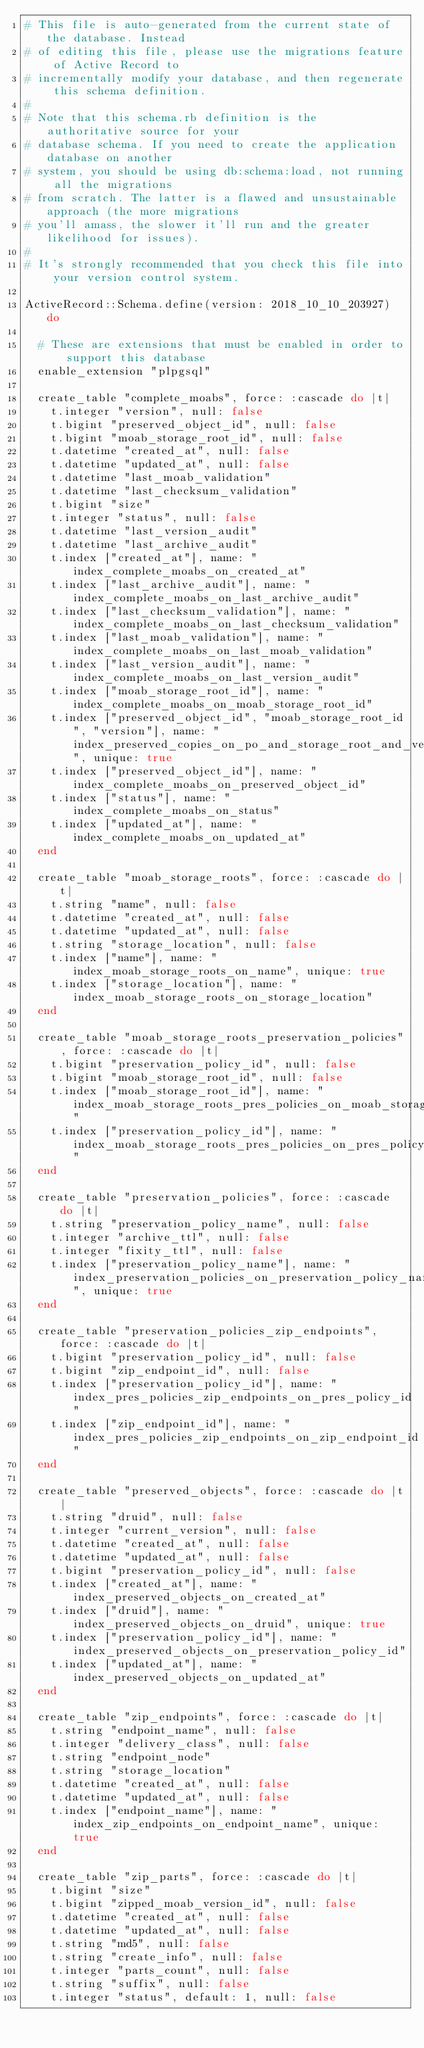Convert code to text. <code><loc_0><loc_0><loc_500><loc_500><_Ruby_># This file is auto-generated from the current state of the database. Instead
# of editing this file, please use the migrations feature of Active Record to
# incrementally modify your database, and then regenerate this schema definition.
#
# Note that this schema.rb definition is the authoritative source for your
# database schema. If you need to create the application database on another
# system, you should be using db:schema:load, not running all the migrations
# from scratch. The latter is a flawed and unsustainable approach (the more migrations
# you'll amass, the slower it'll run and the greater likelihood for issues).
#
# It's strongly recommended that you check this file into your version control system.

ActiveRecord::Schema.define(version: 2018_10_10_203927) do

  # These are extensions that must be enabled in order to support this database
  enable_extension "plpgsql"

  create_table "complete_moabs", force: :cascade do |t|
    t.integer "version", null: false
    t.bigint "preserved_object_id", null: false
    t.bigint "moab_storage_root_id", null: false
    t.datetime "created_at", null: false
    t.datetime "updated_at", null: false
    t.datetime "last_moab_validation"
    t.datetime "last_checksum_validation"
    t.bigint "size"
    t.integer "status", null: false
    t.datetime "last_version_audit"
    t.datetime "last_archive_audit"
    t.index ["created_at"], name: "index_complete_moabs_on_created_at"
    t.index ["last_archive_audit"], name: "index_complete_moabs_on_last_archive_audit"
    t.index ["last_checksum_validation"], name: "index_complete_moabs_on_last_checksum_validation"
    t.index ["last_moab_validation"], name: "index_complete_moabs_on_last_moab_validation"
    t.index ["last_version_audit"], name: "index_complete_moabs_on_last_version_audit"
    t.index ["moab_storage_root_id"], name: "index_complete_moabs_on_moab_storage_root_id"
    t.index ["preserved_object_id", "moab_storage_root_id", "version"], name: "index_preserved_copies_on_po_and_storage_root_and_version", unique: true
    t.index ["preserved_object_id"], name: "index_complete_moabs_on_preserved_object_id"
    t.index ["status"], name: "index_complete_moabs_on_status"
    t.index ["updated_at"], name: "index_complete_moabs_on_updated_at"
  end

  create_table "moab_storage_roots", force: :cascade do |t|
    t.string "name", null: false
    t.datetime "created_at", null: false
    t.datetime "updated_at", null: false
    t.string "storage_location", null: false
    t.index ["name"], name: "index_moab_storage_roots_on_name", unique: true
    t.index ["storage_location"], name: "index_moab_storage_roots_on_storage_location"
  end

  create_table "moab_storage_roots_preservation_policies", force: :cascade do |t|
    t.bigint "preservation_policy_id", null: false
    t.bigint "moab_storage_root_id", null: false
    t.index ["moab_storage_root_id"], name: "index_moab_storage_roots_pres_policies_on_moab_storage_root_id"
    t.index ["preservation_policy_id"], name: "index_moab_storage_roots_pres_policies_on_pres_policy_id"
  end

  create_table "preservation_policies", force: :cascade do |t|
    t.string "preservation_policy_name", null: false
    t.integer "archive_ttl", null: false
    t.integer "fixity_ttl", null: false
    t.index ["preservation_policy_name"], name: "index_preservation_policies_on_preservation_policy_name", unique: true
  end

  create_table "preservation_policies_zip_endpoints", force: :cascade do |t|
    t.bigint "preservation_policy_id", null: false
    t.bigint "zip_endpoint_id", null: false
    t.index ["preservation_policy_id"], name: "index_pres_policies_zip_endpoints_on_pres_policy_id"
    t.index ["zip_endpoint_id"], name: "index_pres_policies_zip_endpoints_on_zip_endpoint_id"
  end

  create_table "preserved_objects", force: :cascade do |t|
    t.string "druid", null: false
    t.integer "current_version", null: false
    t.datetime "created_at", null: false
    t.datetime "updated_at", null: false
    t.bigint "preservation_policy_id", null: false
    t.index ["created_at"], name: "index_preserved_objects_on_created_at"
    t.index ["druid"], name: "index_preserved_objects_on_druid", unique: true
    t.index ["preservation_policy_id"], name: "index_preserved_objects_on_preservation_policy_id"
    t.index ["updated_at"], name: "index_preserved_objects_on_updated_at"
  end

  create_table "zip_endpoints", force: :cascade do |t|
    t.string "endpoint_name", null: false
    t.integer "delivery_class", null: false
    t.string "endpoint_node"
    t.string "storage_location"
    t.datetime "created_at", null: false
    t.datetime "updated_at", null: false
    t.index ["endpoint_name"], name: "index_zip_endpoints_on_endpoint_name", unique: true
  end

  create_table "zip_parts", force: :cascade do |t|
    t.bigint "size"
    t.bigint "zipped_moab_version_id", null: false
    t.datetime "created_at", null: false
    t.datetime "updated_at", null: false
    t.string "md5", null: false
    t.string "create_info", null: false
    t.integer "parts_count", null: false
    t.string "suffix", null: false
    t.integer "status", default: 1, null: false</code> 